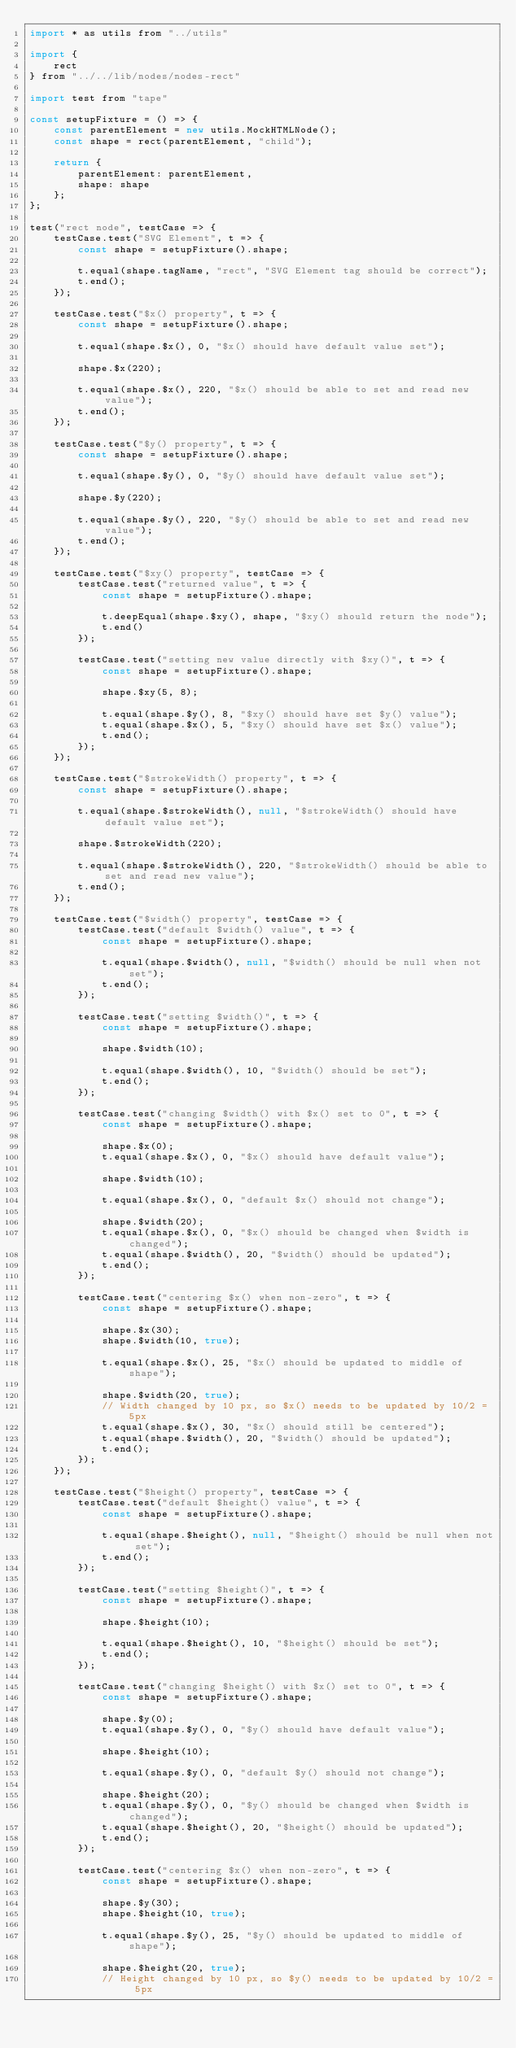<code> <loc_0><loc_0><loc_500><loc_500><_JavaScript_>import * as utils from "../utils"

import {
    rect
} from "../../lib/nodes/nodes-rect"

import test from "tape"

const setupFixture = () => {
    const parentElement = new utils.MockHTMLNode();
    const shape = rect(parentElement, "child");

    return {
        parentElement: parentElement,
        shape: shape
    };
};

test("rect node", testCase => {
    testCase.test("SVG Element", t => {
        const shape = setupFixture().shape;

        t.equal(shape.tagName, "rect", "SVG Element tag should be correct");
        t.end();
    });

    testCase.test("$x() property", t => {
        const shape = setupFixture().shape;

        t.equal(shape.$x(), 0, "$x() should have default value set");

        shape.$x(220);

        t.equal(shape.$x(), 220, "$x() should be able to set and read new value");
        t.end();
    });

    testCase.test("$y() property", t => {
        const shape = setupFixture().shape;

        t.equal(shape.$y(), 0, "$y() should have default value set");

        shape.$y(220);

        t.equal(shape.$y(), 220, "$y() should be able to set and read new value");
        t.end();
    });

    testCase.test("$xy() property", testCase => {
        testCase.test("returned value", t => {
            const shape = setupFixture().shape;

            t.deepEqual(shape.$xy(), shape, "$xy() should return the node");
            t.end()
        });

        testCase.test("setting new value directly with $xy()", t => {
            const shape = setupFixture().shape;

            shape.$xy(5, 8);

            t.equal(shape.$y(), 8, "$xy() should have set $y() value");
            t.equal(shape.$x(), 5, "$xy() should have set $x() value");
            t.end();
        });
    });

    testCase.test("$strokeWidth() property", t => {
        const shape = setupFixture().shape;

        t.equal(shape.$strokeWidth(), null, "$strokeWidth() should have default value set");

        shape.$strokeWidth(220);

        t.equal(shape.$strokeWidth(), 220, "$strokeWidth() should be able to set and read new value");
        t.end();
    });

    testCase.test("$width() property", testCase => {
        testCase.test("default $width() value", t => {
            const shape = setupFixture().shape;

            t.equal(shape.$width(), null, "$width() should be null when not set");
            t.end();
        });

        testCase.test("setting $width()", t => {
            const shape = setupFixture().shape;

            shape.$width(10);

            t.equal(shape.$width(), 10, "$width() should be set");
            t.end();
        });

        testCase.test("changing $width() with $x() set to 0", t => {
            const shape = setupFixture().shape;

            shape.$x(0);
            t.equal(shape.$x(), 0, "$x() should have default value");

            shape.$width(10);

            t.equal(shape.$x(), 0, "default $x() should not change");

            shape.$width(20);
            t.equal(shape.$x(), 0, "$x() should be changed when $width is changed");
            t.equal(shape.$width(), 20, "$width() should be updated");
            t.end();
        });

        testCase.test("centering $x() when non-zero", t => {
            const shape = setupFixture().shape;

            shape.$x(30);
            shape.$width(10, true);

            t.equal(shape.$x(), 25, "$x() should be updated to middle of shape");

            shape.$width(20, true);
            // Width changed by 10 px, so $x() needs to be updated by 10/2 = 5px
            t.equal(shape.$x(), 30, "$x() should still be centered");
            t.equal(shape.$width(), 20, "$width() should be updated");
            t.end();
        });
    });

    testCase.test("$height() property", testCase => {
        testCase.test("default $height() value", t => {
            const shape = setupFixture().shape;

            t.equal(shape.$height(), null, "$height() should be null when not set");
            t.end();
        });

        testCase.test("setting $height()", t => {
            const shape = setupFixture().shape;

            shape.$height(10);

            t.equal(shape.$height(), 10, "$height() should be set");
            t.end();
        });

        testCase.test("changing $height() with $x() set to 0", t => {
            const shape = setupFixture().shape;

            shape.$y(0);
            t.equal(shape.$y(), 0, "$y() should have default value");

            shape.$height(10);

            t.equal(shape.$y(), 0, "default $y() should not change");

            shape.$height(20);
            t.equal(shape.$y(), 0, "$y() should be changed when $width is changed");
            t.equal(shape.$height(), 20, "$height() should be updated");
            t.end();
        });

        testCase.test("centering $x() when non-zero", t => {
            const shape = setupFixture().shape;

            shape.$y(30);
            shape.$height(10, true);

            t.equal(shape.$y(), 25, "$y() should be updated to middle of shape");

            shape.$height(20, true);
            // Height changed by 10 px, so $y() needs to be updated by 10/2 = 5px</code> 